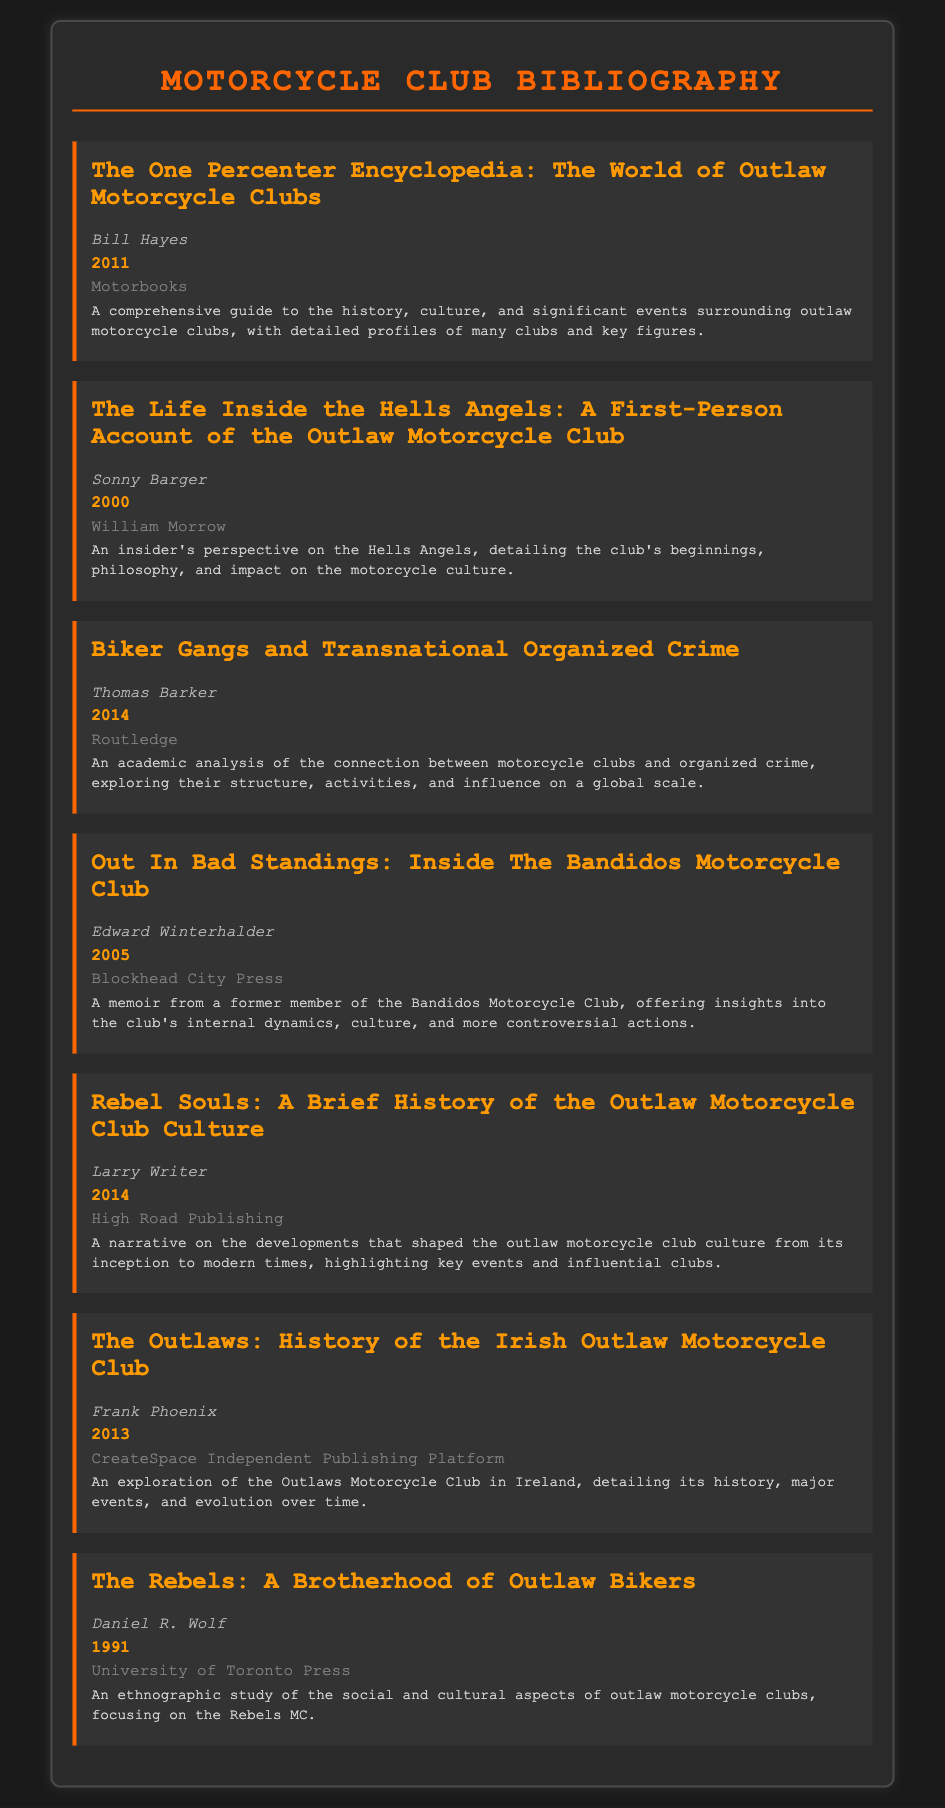What is the title of the book by Bill Hayes? The title of the book authored by Bill Hayes listed in the document is specifically mentioned as "The One Percenter Encyclopedia: The World of Outlaw Motorcycle Clubs."
Answer: The One Percenter Encyclopedia: The World of Outlaw Motorcycle Clubs Who wrote "The Life Inside the Hells Angels"? The document specifies the author of "The Life Inside the Hells Angels" as Sonny Barger.
Answer: Sonny Barger In what year was "Biker Gangs and Transnational Organized Crime" published? The publication year for the book "Biker Gangs and Transnational Organized Crime" is listed as 2014 in the document.
Answer: 2014 What publisher released the memoir about the Bandidos Motorcycle Club? According to the document, "Out In Bad Standings: Inside The Bandidos Motorcycle Club" was published by Blockhead City Press.
Answer: Blockhead City Press Which book focuses on the Hells Angels? The title of the book focusing on the Hells Angels provided in the document is "The Life Inside the Hells Angels: A First-Person Account of the Outlaw Motorcycle Club."
Answer: The Life Inside the Hells Angels: A First-Person Account of the Outlaw Motorcycle Club Name one key theme covered in "Rebel Souls." The document indicates that "Rebel Souls" covers the developments that shaped outlaw motorcycle club culture, highlighting key events and influential clubs.
Answer: Outlaw motorcycle club culture How many books are authored by Frank Phoenix in the bibliography? There is only one book listed in the document authored by Frank Phoenix, which is "The Outlaws: History of the Irish Outlaw Motorcycle Club."
Answer: One What is the main focus of "The Rebels: A Brotherhood of Outlaw Bikers"? The book "The Rebels: A Brotherhood of Outlaw Bikers" presents an ethnographic study of the social and cultural aspects of outlaw motorcycle clubs.
Answer: Ethnographic study Who published "Rebel Souls"? The document states that "Rebel Souls" was published by High Road Publishing.
Answer: High Road Publishing 